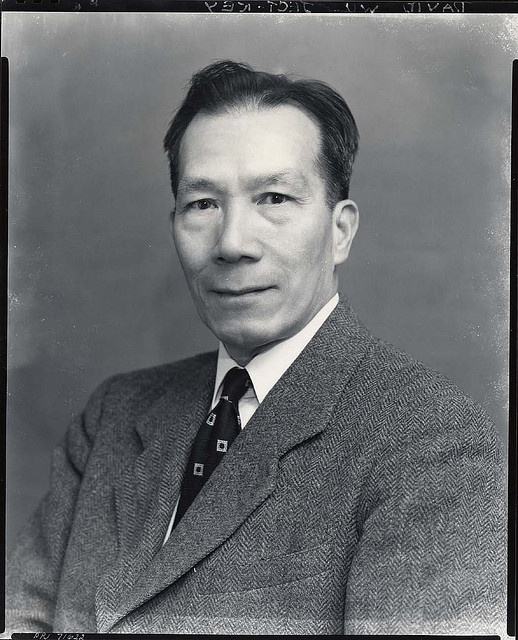Describe the objects in this image and their specific colors. I can see people in black, gray, darkgray, and lightgray tones and tie in black, gray, darkgray, and lightgray tones in this image. 